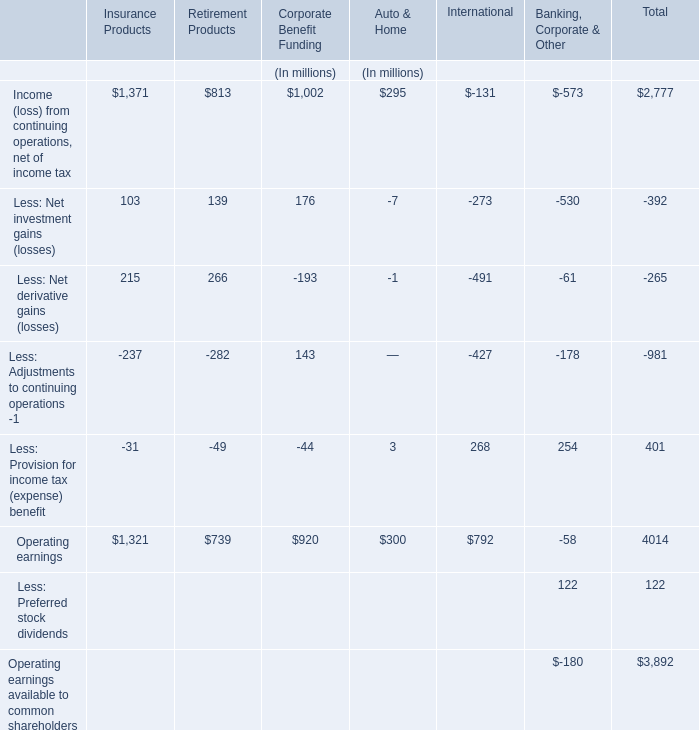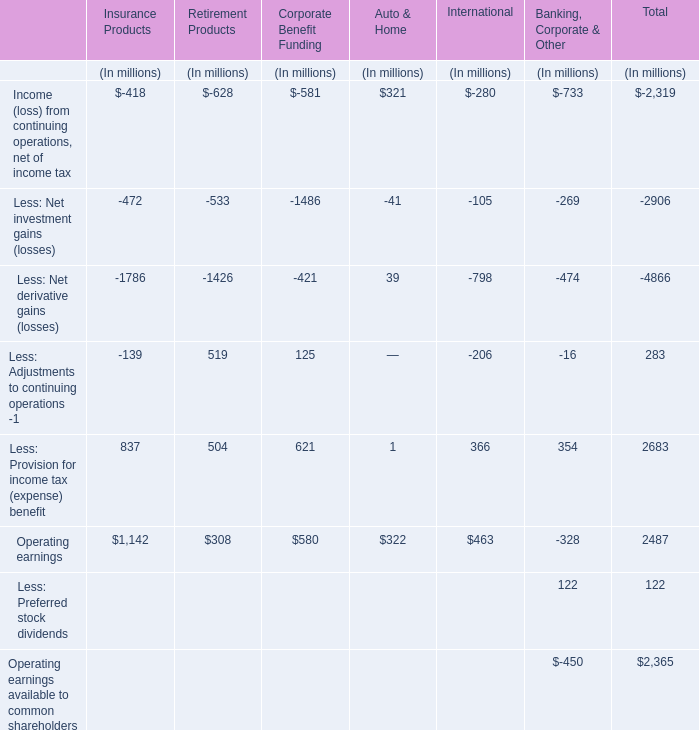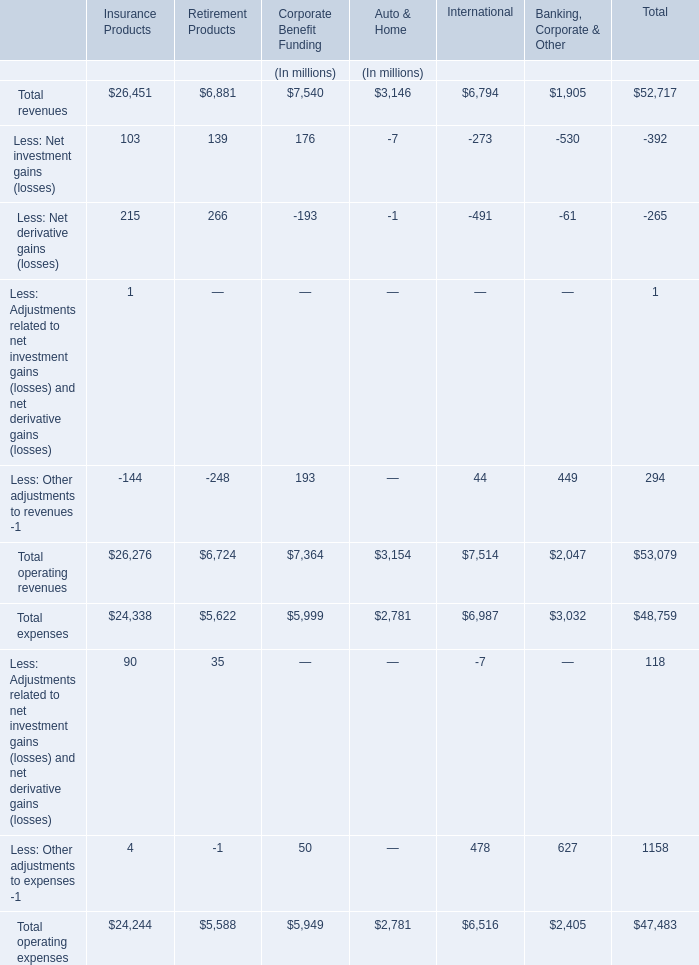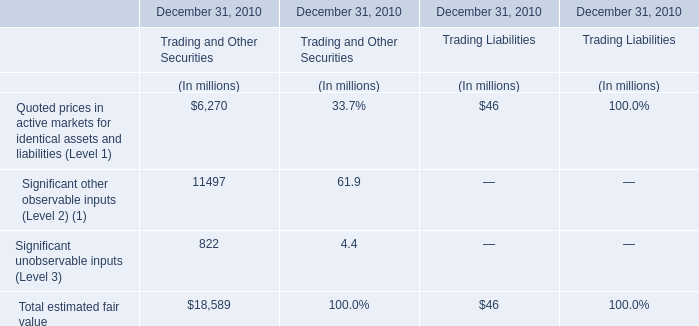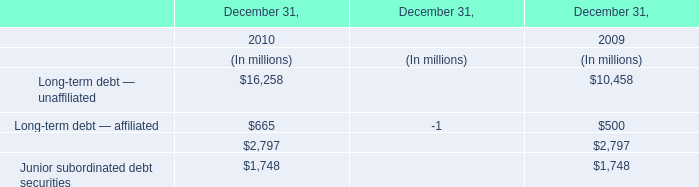Except Section Total,what is the Operating earnings of the section where Less: Provision for income tax (expense) benefit exceeds 30 % of total Operating earnings? (in million) 
Answer: 1142. 